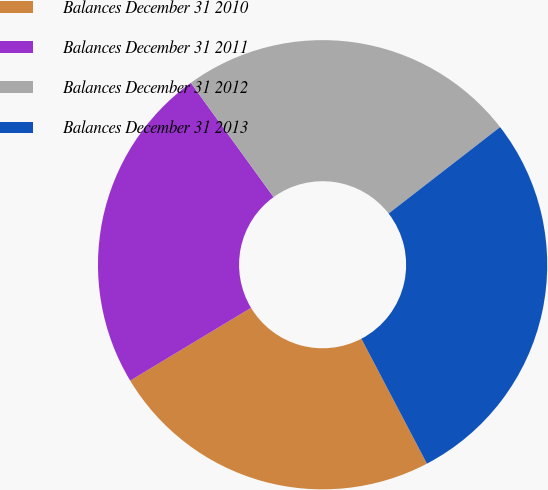Convert chart to OTSL. <chart><loc_0><loc_0><loc_500><loc_500><pie_chart><fcel>Balances December 31 2010<fcel>Balances December 31 2011<fcel>Balances December 31 2012<fcel>Balances December 31 2013<nl><fcel>24.06%<fcel>23.65%<fcel>24.48%<fcel>27.81%<nl></chart> 